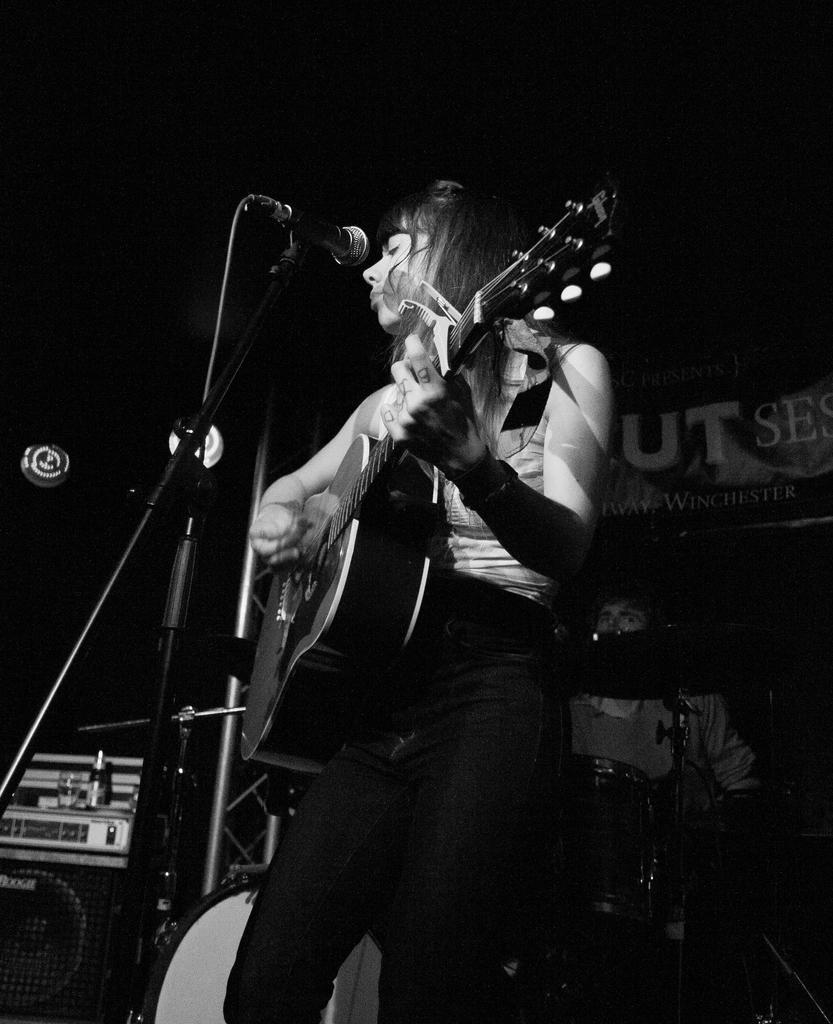How would you summarize this image in a sentence or two? Here a woman is playing guitar. There is a microphone and behind her there are few people and musical instruments. 